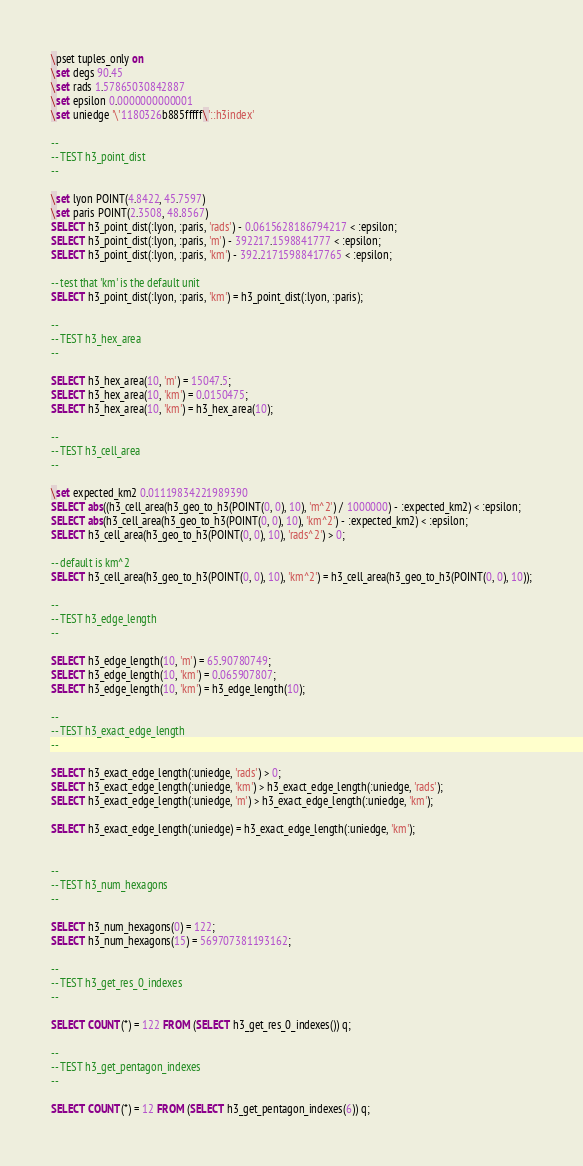<code> <loc_0><loc_0><loc_500><loc_500><_SQL_>\pset tuples_only on
\set degs 90.45
\set rads 1.57865030842887
\set epsilon 0.0000000000001
\set uniedge '\'1180326b885fffff\'::h3index'

--
-- TEST h3_point_dist
--

\set lyon POINT(4.8422, 45.7597)
\set paris POINT(2.3508, 48.8567)
SELECT h3_point_dist(:lyon, :paris, 'rads') - 0.0615628186794217 < :epsilon;
SELECT h3_point_dist(:lyon, :paris, 'm') - 392217.1598841777 < :epsilon;
SELECT h3_point_dist(:lyon, :paris, 'km') - 392.21715988417765 < :epsilon;

-- test that 'km' is the default unit
SELECT h3_point_dist(:lyon, :paris, 'km') = h3_point_dist(:lyon, :paris);

--
-- TEST h3_hex_area
--

SELECT h3_hex_area(10, 'm') = 15047.5;
SELECT h3_hex_area(10, 'km') = 0.0150475;
SELECT h3_hex_area(10, 'km') = h3_hex_area(10);

--
-- TEST h3_cell_area
--

\set expected_km2 0.01119834221989390
SELECT abs((h3_cell_area(h3_geo_to_h3(POINT(0, 0), 10), 'm^2') / 1000000) - :expected_km2) < :epsilon;
SELECT abs(h3_cell_area(h3_geo_to_h3(POINT(0, 0), 10), 'km^2') - :expected_km2) < :epsilon;
SELECT h3_cell_area(h3_geo_to_h3(POINT(0, 0), 10), 'rads^2') > 0;

-- default is km^2
SELECT h3_cell_area(h3_geo_to_h3(POINT(0, 0), 10), 'km^2') = h3_cell_area(h3_geo_to_h3(POINT(0, 0), 10));

--
-- TEST h3_edge_length
--

SELECT h3_edge_length(10, 'm') = 65.90780749;
SELECT h3_edge_length(10, 'km') = 0.065907807;
SELECT h3_edge_length(10, 'km') = h3_edge_length(10);

--
-- TEST h3_exact_edge_length
--

SELECT h3_exact_edge_length(:uniedge, 'rads') > 0;
SELECT h3_exact_edge_length(:uniedge, 'km') > h3_exact_edge_length(:uniedge, 'rads');
SELECT h3_exact_edge_length(:uniedge, 'm') > h3_exact_edge_length(:uniedge, 'km');

SELECT h3_exact_edge_length(:uniedge) = h3_exact_edge_length(:uniedge, 'km');


--
-- TEST h3_num_hexagons
--

SELECT h3_num_hexagons(0) = 122;
SELECT h3_num_hexagons(15) = 569707381193162;

--
-- TEST h3_get_res_0_indexes
--

SELECT COUNT(*) = 122 FROM (SELECT h3_get_res_0_indexes()) q;

--
-- TEST h3_get_pentagon_indexes
--

SELECT COUNT(*) = 12 FROM (SELECT h3_get_pentagon_indexes(6)) q; </code> 